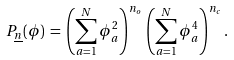<formula> <loc_0><loc_0><loc_500><loc_500>P _ { \underline { n } } ( \phi ) \, = \, \left ( \sum _ { a = 1 } ^ { N } \phi _ { a } ^ { 2 } \right ) ^ { n _ { o } } \, \left ( \sum _ { a = 1 } ^ { N } \phi _ { a } ^ { 4 } \right ) ^ { n _ { c } } .</formula> 